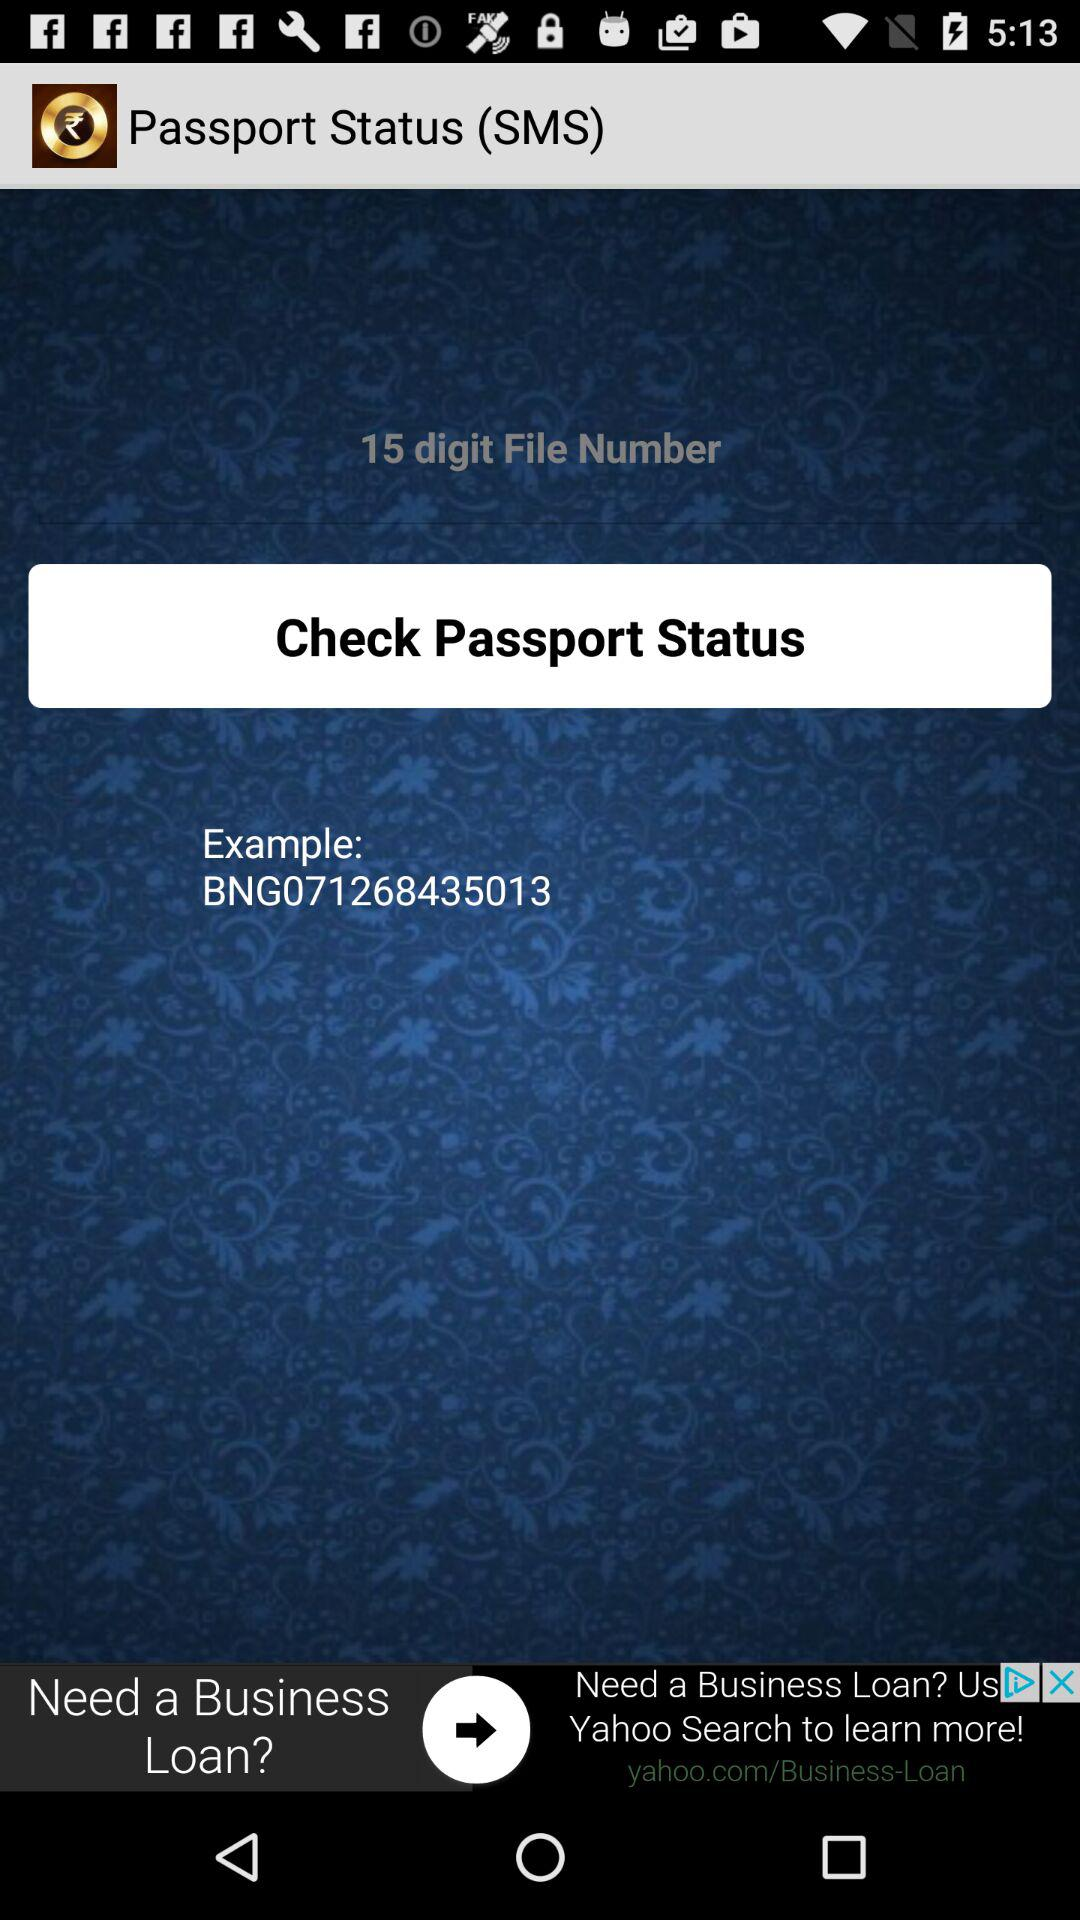How many digits are there in the file number? These are 15 digits in the file number. 